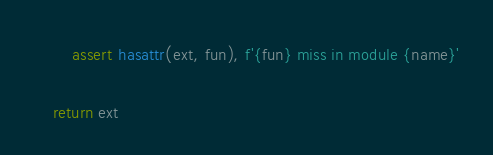Convert code to text. <code><loc_0><loc_0><loc_500><loc_500><_Python_>        assert hasattr(ext, fun), f'{fun} miss in module {name}'

    return ext
</code> 